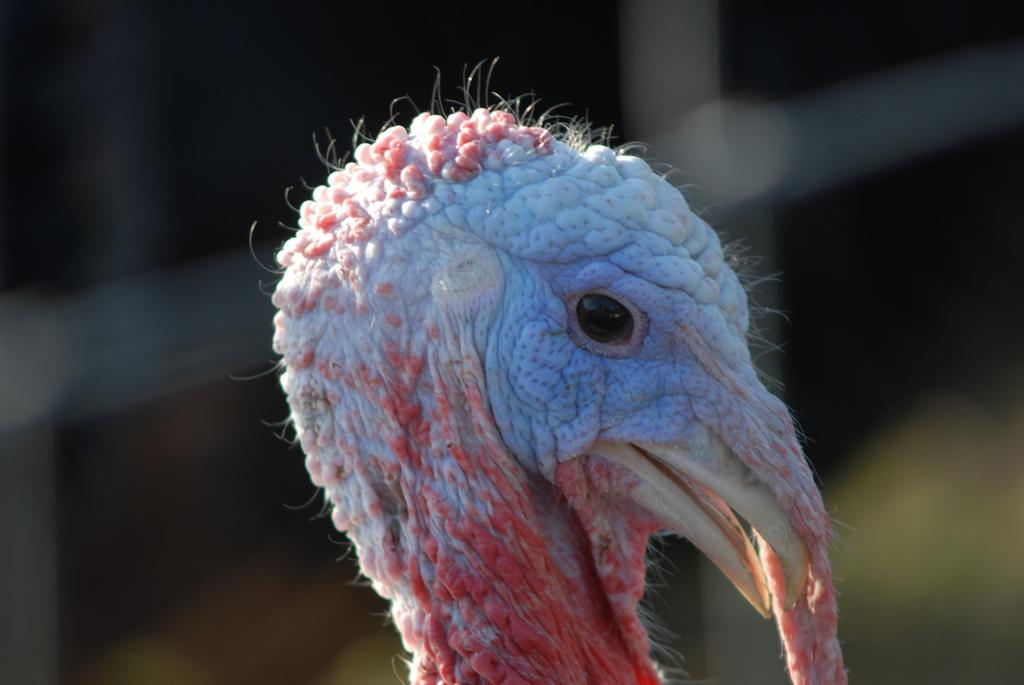What is the main subject of the image? The main subject of the image is a bird's head. Can you describe the background of the image? The background of the image is blurry. What type of ornament is hanging from the bird's beak in the image? There is no ornament hanging from the bird's beak in the image; it only shows the bird's head. What government policies are being discussed in the image? There is no discussion of government policies in the image; it only shows the bird's head. 